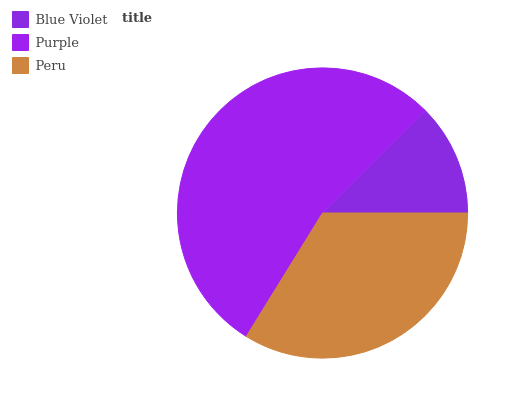Is Blue Violet the minimum?
Answer yes or no. Yes. Is Purple the maximum?
Answer yes or no. Yes. Is Peru the minimum?
Answer yes or no. No. Is Peru the maximum?
Answer yes or no. No. Is Purple greater than Peru?
Answer yes or no. Yes. Is Peru less than Purple?
Answer yes or no. Yes. Is Peru greater than Purple?
Answer yes or no. No. Is Purple less than Peru?
Answer yes or no. No. Is Peru the high median?
Answer yes or no. Yes. Is Peru the low median?
Answer yes or no. Yes. Is Purple the high median?
Answer yes or no. No. Is Purple the low median?
Answer yes or no. No. 